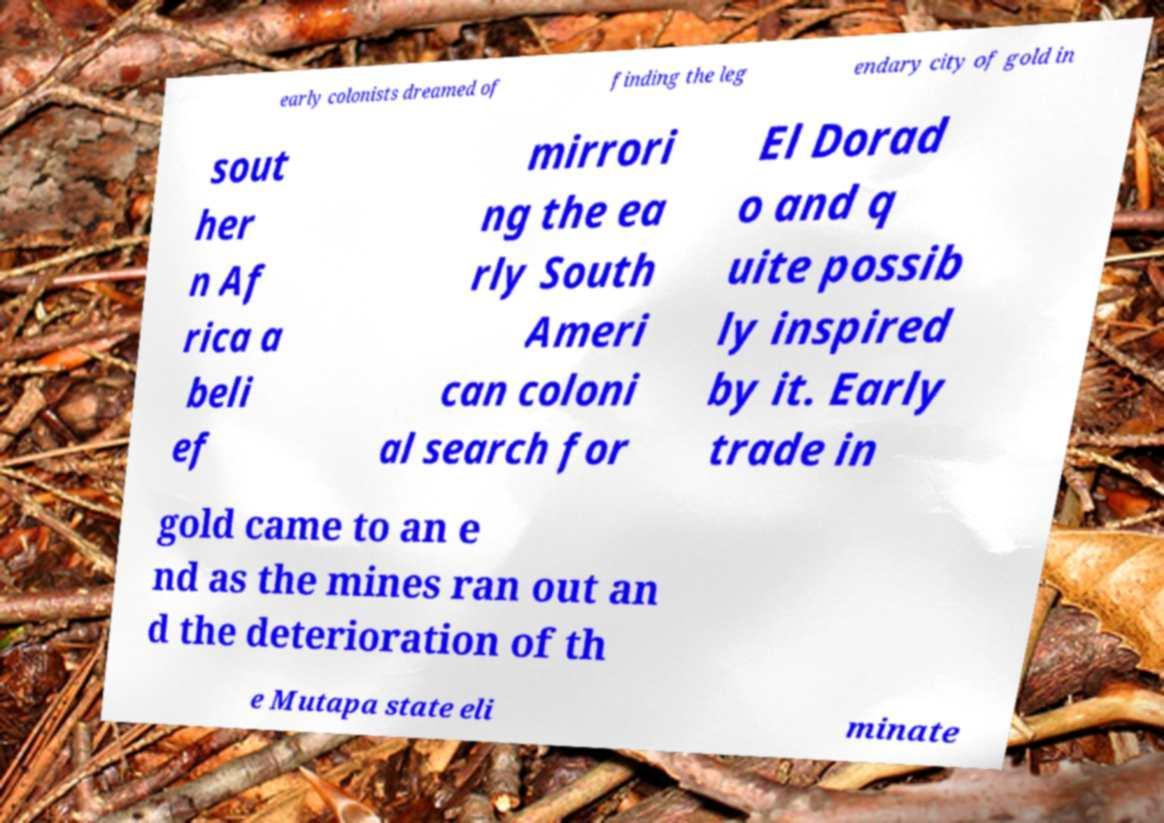Could you extract and type out the text from this image? early colonists dreamed of finding the leg endary city of gold in sout her n Af rica a beli ef mirrori ng the ea rly South Ameri can coloni al search for El Dorad o and q uite possib ly inspired by it. Early trade in gold came to an e nd as the mines ran out an d the deterioration of th e Mutapa state eli minate 